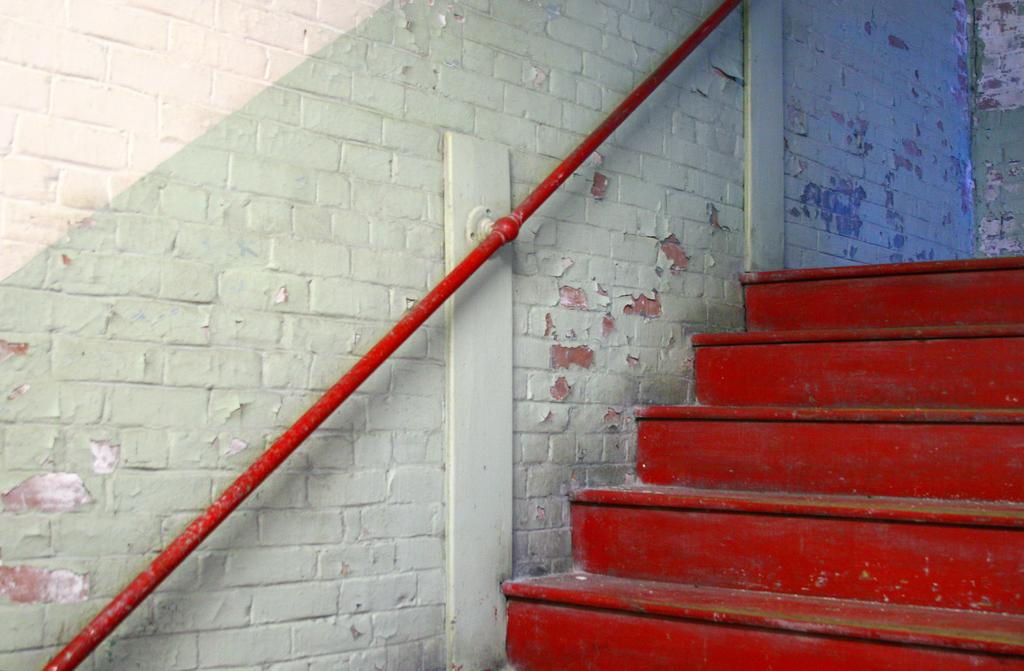What is the main subject in the center of the image? There is a staircase in the center of the image. What can be seen in the background of the image? There is a wall and a pole in the background of the image. What type of harmony can be heard being played on the banana in the image? There is no banana present in the image, and therefore no such harmony can be heard. 